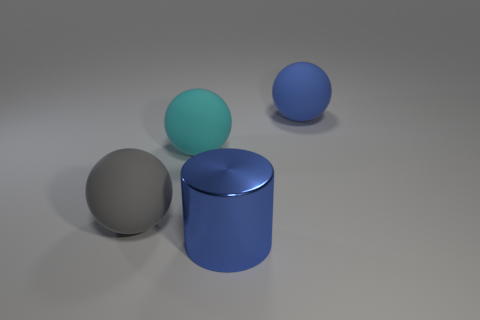Add 4 big blue shiny blocks. How many objects exist? 8 Subtract all cylinders. How many objects are left? 3 Subtract 0 brown cubes. How many objects are left? 4 Subtract all large blue metal things. Subtract all blue cylinders. How many objects are left? 2 Add 4 big gray balls. How many big gray balls are left? 5 Add 1 tiny brown spheres. How many tiny brown spheres exist? 1 